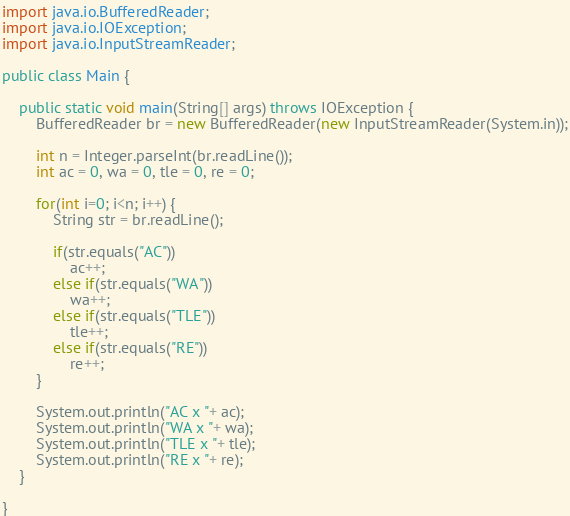Convert code to text. <code><loc_0><loc_0><loc_500><loc_500><_Java_>import java.io.BufferedReader;
import java.io.IOException;
import java.io.InputStreamReader;

public class Main {

	public static void main(String[] args) throws IOException {
		BufferedReader br = new BufferedReader(new InputStreamReader(System.in));
		
		int n = Integer.parseInt(br.readLine());
		int ac = 0, wa = 0, tle = 0, re = 0;
		
		for(int i=0; i<n; i++) {
			String str = br.readLine();
			
			if(str.equals("AC"))
				ac++;
			else if(str.equals("WA"))
				wa++;
			else if(str.equals("TLE"))
				tle++;
			else if(str.equals("RE"))
				re++;
		}
		
		System.out.println("AC x "+ ac);
		System.out.println("WA x "+ wa);
		System.out.println("TLE x "+ tle);
		System.out.println("RE x "+ re);
	}

}</code> 